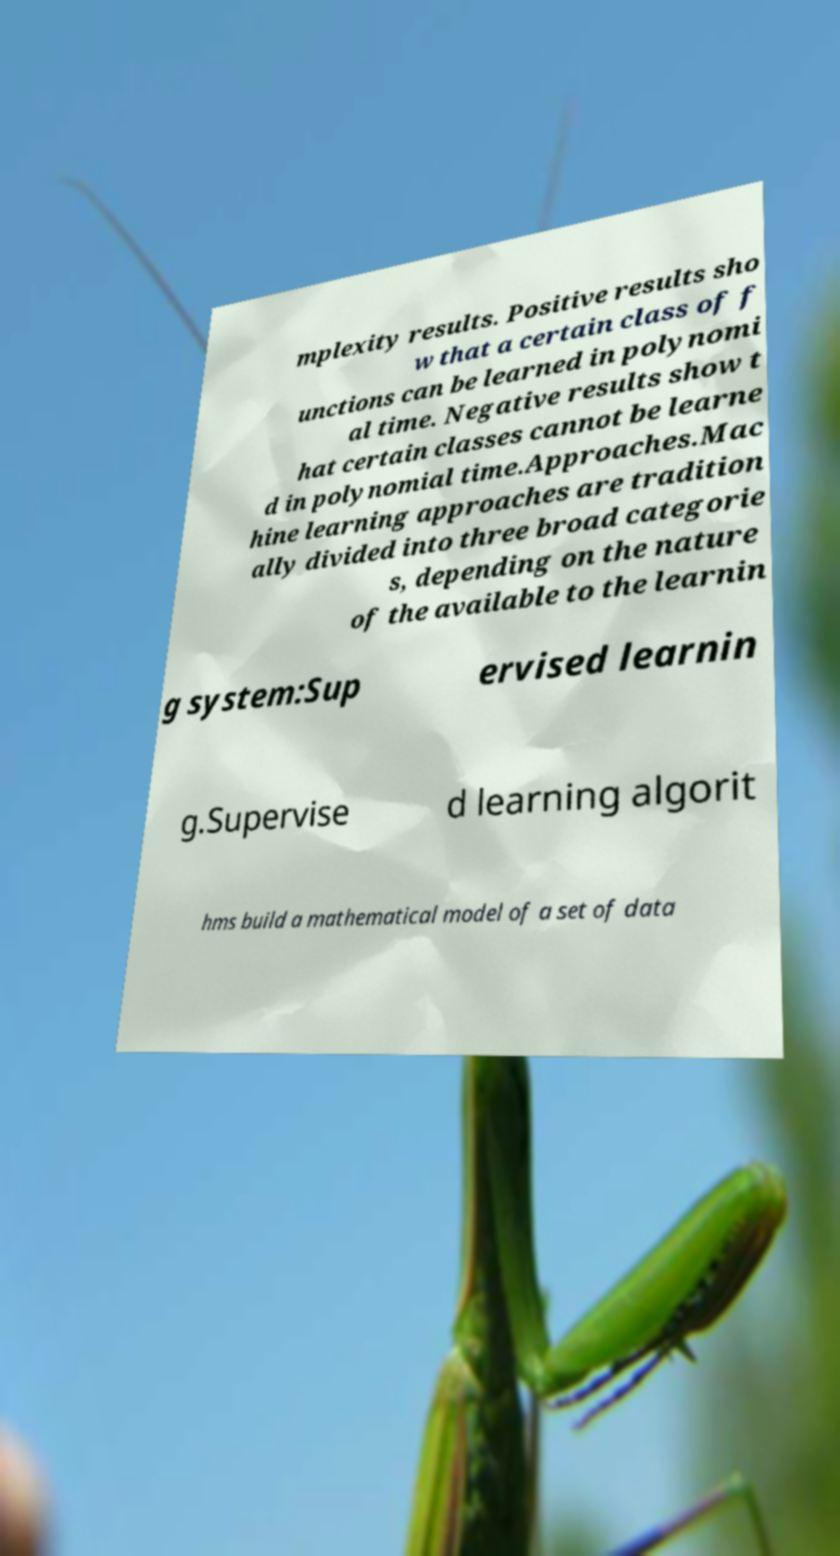I need the written content from this picture converted into text. Can you do that? mplexity results. Positive results sho w that a certain class of f unctions can be learned in polynomi al time. Negative results show t hat certain classes cannot be learne d in polynomial time.Approaches.Mac hine learning approaches are tradition ally divided into three broad categorie s, depending on the nature of the available to the learnin g system:Sup ervised learnin g.Supervise d learning algorit hms build a mathematical model of a set of data 